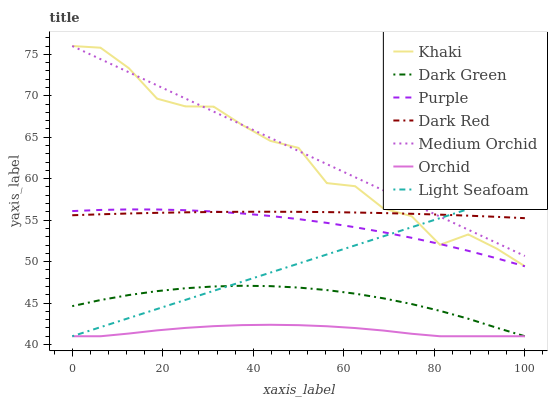Does Orchid have the minimum area under the curve?
Answer yes or no. Yes. Does Medium Orchid have the maximum area under the curve?
Answer yes or no. Yes. Does Purple have the minimum area under the curve?
Answer yes or no. No. Does Purple have the maximum area under the curve?
Answer yes or no. No. Is Medium Orchid the smoothest?
Answer yes or no. Yes. Is Khaki the roughest?
Answer yes or no. Yes. Is Purple the smoothest?
Answer yes or no. No. Is Purple the roughest?
Answer yes or no. No. Does Dark Green have the lowest value?
Answer yes or no. Yes. Does Purple have the lowest value?
Answer yes or no. No. Does Medium Orchid have the highest value?
Answer yes or no. Yes. Does Purple have the highest value?
Answer yes or no. No. Is Orchid less than Dark Red?
Answer yes or no. Yes. Is Medium Orchid greater than Purple?
Answer yes or no. Yes. Does Dark Green intersect Orchid?
Answer yes or no. Yes. Is Dark Green less than Orchid?
Answer yes or no. No. Is Dark Green greater than Orchid?
Answer yes or no. No. Does Orchid intersect Dark Red?
Answer yes or no. No. 